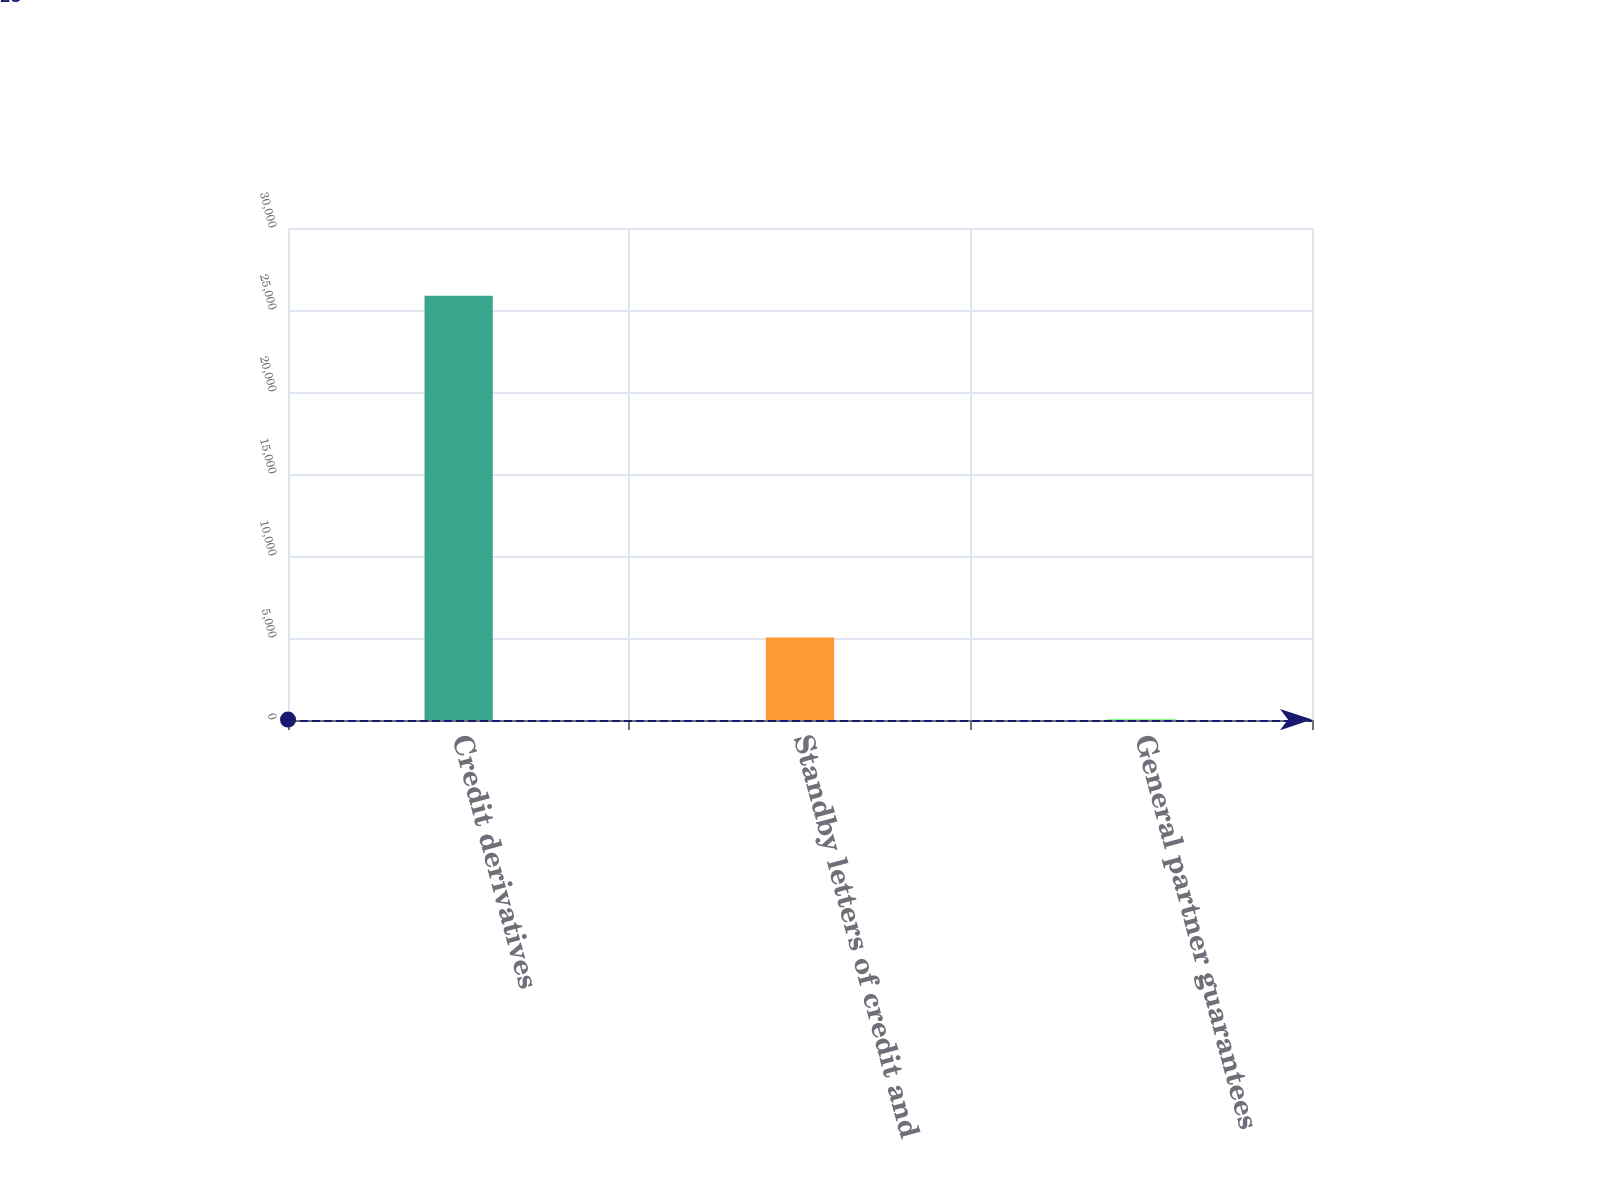Convert chart. <chart><loc_0><loc_0><loc_500><loc_500><bar_chart><fcel>Credit derivatives<fcel>Standby letters of credit and<fcel>General partner guarantees<nl><fcel>25876<fcel>5036<fcel>25<nl></chart> 